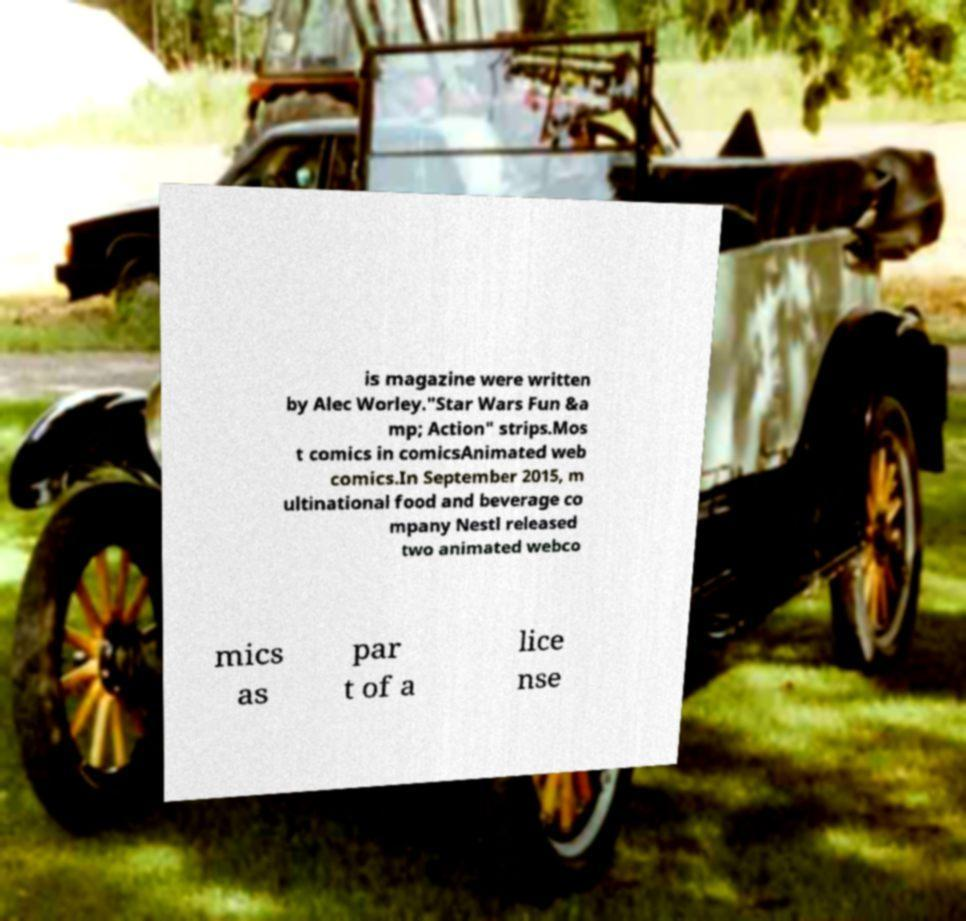What messages or text are displayed in this image? I need them in a readable, typed format. is magazine were written by Alec Worley."Star Wars Fun &a mp; Action" strips.Mos t comics in comicsAnimated web comics.In September 2015, m ultinational food and beverage co mpany Nestl released two animated webco mics as par t of a lice nse 